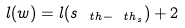<formula> <loc_0><loc_0><loc_500><loc_500>l ( w ) = l ( s _ { \ t h - \ t h _ { s } } ) + 2</formula> 